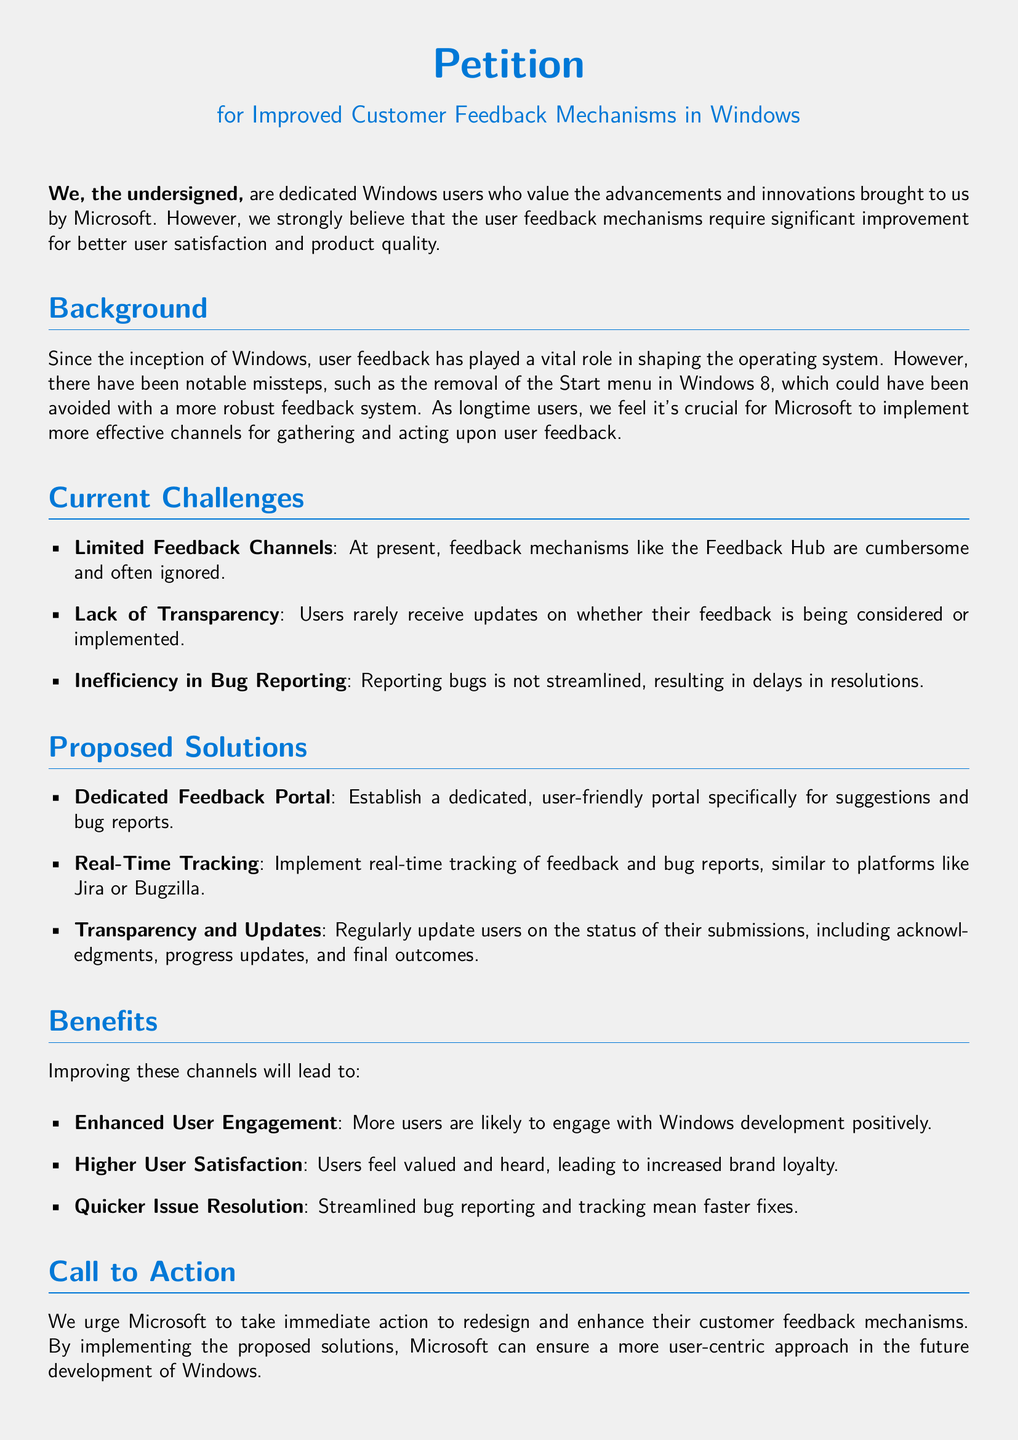What is the title of the petition? The title of the petition is located at the top of the document.
Answer: Petition for Improved Customer Feedback Mechanisms in Windows Who are the signers of the petition? The signers of the petition are referred to as "the undersigned" in the document.
Answer: dedicated Windows users What is one of the current challenges mentioned? The document lists challenges related to feedback mechanisms experienced by users.
Answer: Limited Feedback Channels What is a proposed solution for improving feedback mechanisms? The document outlines solutions towards better customer feedback mechanisms.
Answer: Dedicated Feedback Portal What benefit is associated with improved user engagement? The benefits of improving feedback channels are stated clearly in the document.
Answer: Higher User Satisfaction How many challenges are listed in the current challenges section? The number of challenges listed can be counted from the document's current challenges section.
Answer: Three What does the petition urge Microsoft to redesign? The specific element that is urged for redesigning is indicated in the call to action section.
Answer: Customer feedback mechanisms Which color is used for the main headings in the document? The color used for headings can be identified from the document's formatting details.
Answer: winblue 